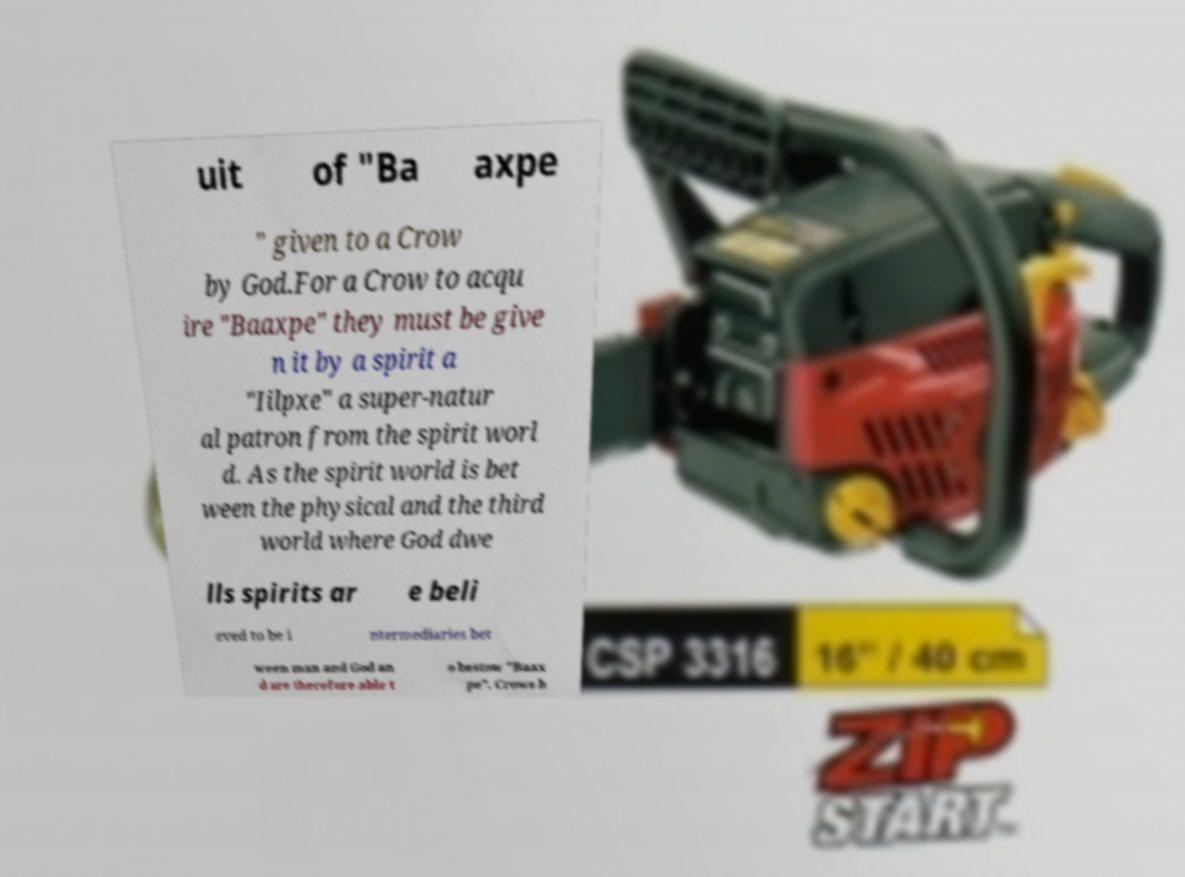I need the written content from this picture converted into text. Can you do that? uit of "Ba axpe " given to a Crow by God.For a Crow to acqu ire "Baaxpe" they must be give n it by a spirit a "Iilpxe" a super-natur al patron from the spirit worl d. As the spirit world is bet ween the physical and the third world where God dwe lls spirits ar e beli eved to be i ntermediaries bet ween man and God an d are therefore able t o bestow "Baax pe". Crows b 